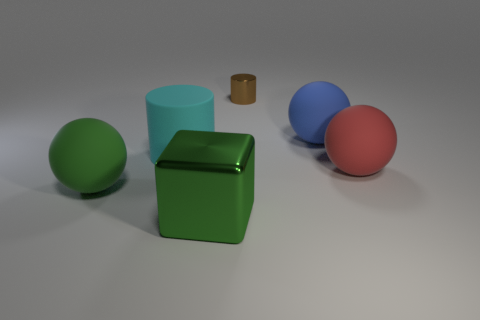Add 2 large blue spheres. How many objects exist? 8 Subtract all cylinders. How many objects are left? 4 Add 3 large green blocks. How many large green blocks are left? 4 Add 1 small cylinders. How many small cylinders exist? 2 Subtract 0 brown blocks. How many objects are left? 6 Subtract all tiny brown things. Subtract all small objects. How many objects are left? 4 